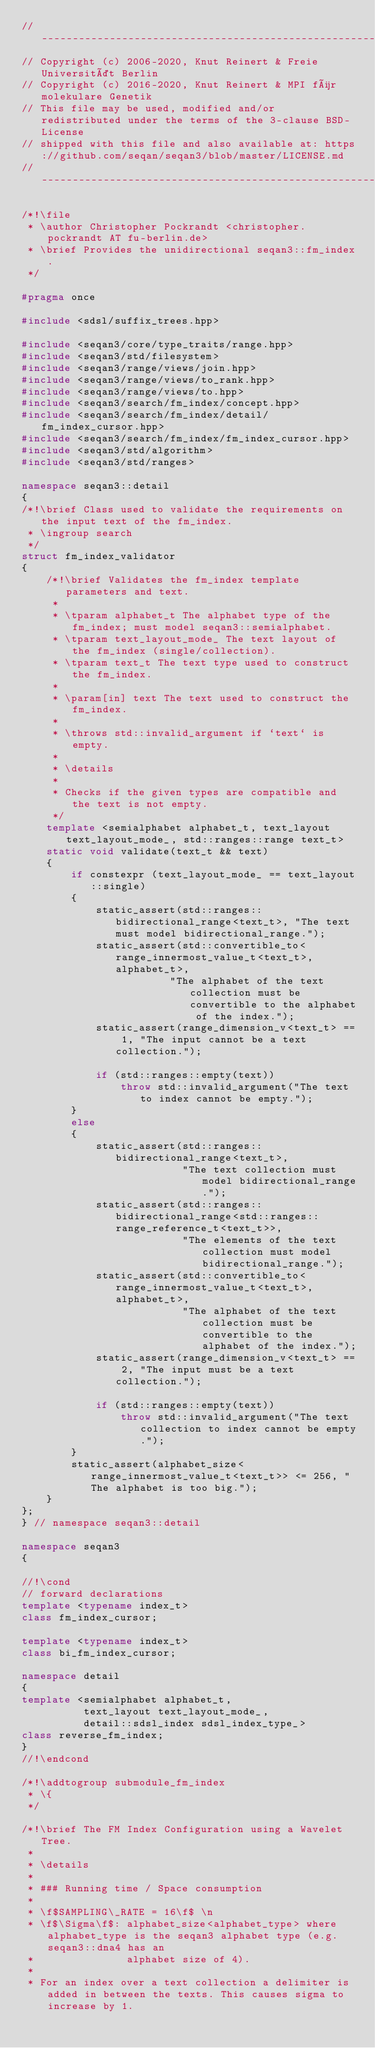<code> <loc_0><loc_0><loc_500><loc_500><_C++_>// -----------------------------------------------------------------------------------------------------
// Copyright (c) 2006-2020, Knut Reinert & Freie Universität Berlin
// Copyright (c) 2016-2020, Knut Reinert & MPI für molekulare Genetik
// This file may be used, modified and/or redistributed under the terms of the 3-clause BSD-License
// shipped with this file and also available at: https://github.com/seqan/seqan3/blob/master/LICENSE.md
// -----------------------------------------------------------------------------------------------------

/*!\file
 * \author Christopher Pockrandt <christopher.pockrandt AT fu-berlin.de>
 * \brief Provides the unidirectional seqan3::fm_index.
 */

#pragma once

#include <sdsl/suffix_trees.hpp>

#include <seqan3/core/type_traits/range.hpp>
#include <seqan3/std/filesystem>
#include <seqan3/range/views/join.hpp>
#include <seqan3/range/views/to_rank.hpp>
#include <seqan3/range/views/to.hpp>
#include <seqan3/search/fm_index/concept.hpp>
#include <seqan3/search/fm_index/detail/fm_index_cursor.hpp>
#include <seqan3/search/fm_index/fm_index_cursor.hpp>
#include <seqan3/std/algorithm>
#include <seqan3/std/ranges>

namespace seqan3::detail
{
/*!\brief Class used to validate the requirements on the input text of the fm_index.
 * \ingroup search
 */
struct fm_index_validator
{
    /*!\brief Validates the fm_index template parameters and text.
     *
     * \tparam alphabet_t The alphabet type of the fm_index; must model seqan3::semialphabet.
     * \tparam text_layout_mode_ The text layout of the fm_index (single/collection).
     * \tparam text_t The text type used to construct the fm_index.
     *
     * \param[in] text The text used to construct the fm_index.
     *
     * \throws std::invalid_argument if `text` is empty.
     *
     * \details
     *
     * Checks if the given types are compatible and the text is not empty.
     */
    template <semialphabet alphabet_t, text_layout text_layout_mode_, std::ranges::range text_t>
    static void validate(text_t && text)
    {
        if constexpr (text_layout_mode_ == text_layout::single)
        {
            static_assert(std::ranges::bidirectional_range<text_t>, "The text must model bidirectional_range.");
            static_assert(std::convertible_to<range_innermost_value_t<text_t>, alphabet_t>,
                        "The alphabet of the text collection must be convertible to the alphabet of the index.");
            static_assert(range_dimension_v<text_t> == 1, "The input cannot be a text collection.");

            if (std::ranges::empty(text))
                throw std::invalid_argument("The text to index cannot be empty.");
        }
        else
        {
            static_assert(std::ranges::bidirectional_range<text_t>,
                          "The text collection must model bidirectional_range.");
            static_assert(std::ranges::bidirectional_range<std::ranges::range_reference_t<text_t>>,
                          "The elements of the text collection must model bidirectional_range.");
            static_assert(std::convertible_to<range_innermost_value_t<text_t>, alphabet_t>,
                          "The alphabet of the text collection must be convertible to the alphabet of the index.");
            static_assert(range_dimension_v<text_t> == 2, "The input must be a text collection.");

            if (std::ranges::empty(text))
                throw std::invalid_argument("The text collection to index cannot be empty.");
        }
        static_assert(alphabet_size<range_innermost_value_t<text_t>> <= 256, "The alphabet is too big.");
    }
};
} // namespace seqan3::detail

namespace seqan3
{

//!\cond
// forward declarations
template <typename index_t>
class fm_index_cursor;

template <typename index_t>
class bi_fm_index_cursor;

namespace detail
{
template <semialphabet alphabet_t,
          text_layout text_layout_mode_,
          detail::sdsl_index sdsl_index_type_>
class reverse_fm_index;
}
//!\endcond

/*!\addtogroup submodule_fm_index
 * \{
 */

/*!\brief The FM Index Configuration using a Wavelet Tree.
 *
 * \details
 *
 * ### Running time / Space consumption
 *
 * \f$SAMPLING\_RATE = 16\f$ \n
 * \f$\Sigma\f$: alphabet_size<alphabet_type> where alphabet_type is the seqan3 alphabet type (e.g. seqan3::dna4 has an
 *               alphabet size of 4).
 *
 * For an index over a text collection a delimiter is added in between the texts. This causes sigma to increase by 1.</code> 